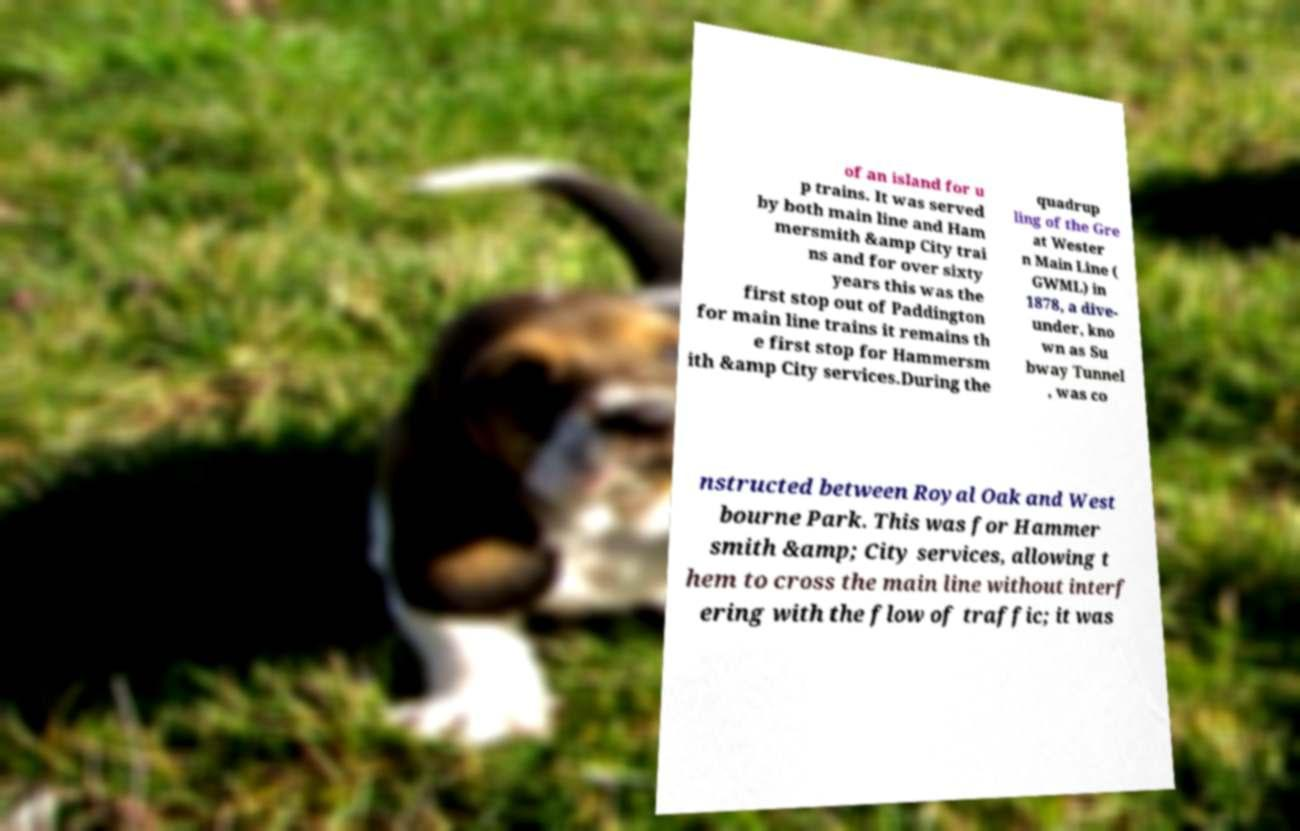Please read and relay the text visible in this image. What does it say? of an island for u p trains. It was served by both main line and Ham mersmith &amp City trai ns and for over sixty years this was the first stop out of Paddington for main line trains it remains th e first stop for Hammersm ith &amp City services.During the quadrup ling of the Gre at Wester n Main Line ( GWML) in 1878, a dive- under, kno wn as Su bway Tunnel , was co nstructed between Royal Oak and West bourne Park. This was for Hammer smith &amp; City services, allowing t hem to cross the main line without interf ering with the flow of traffic; it was 